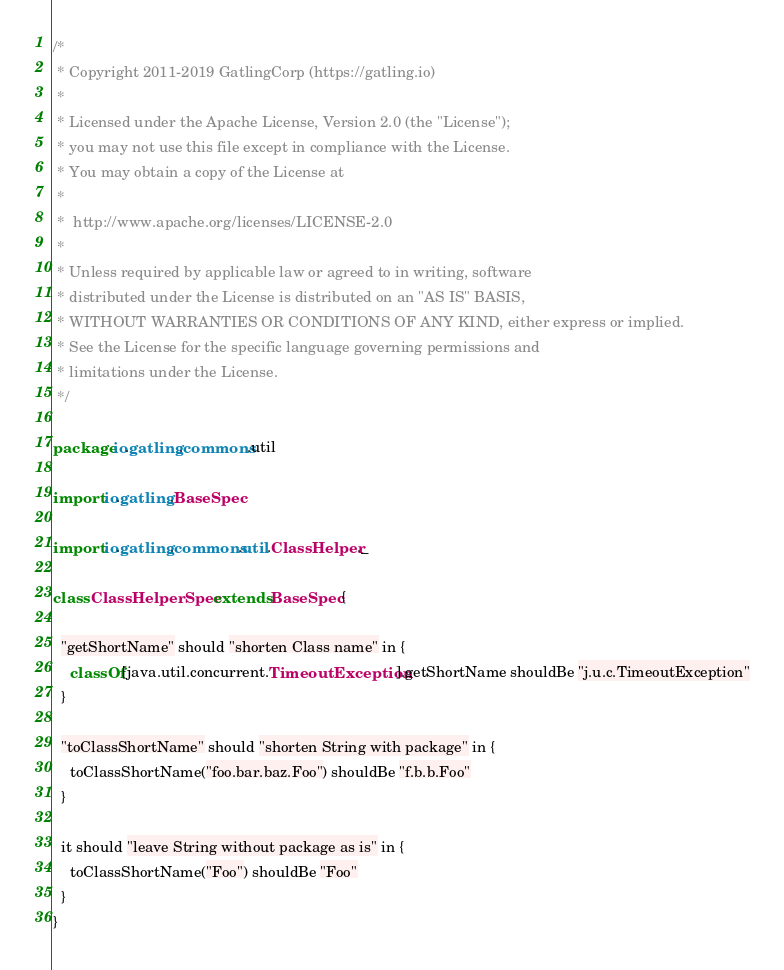Convert code to text. <code><loc_0><loc_0><loc_500><loc_500><_Scala_>/*
 * Copyright 2011-2019 GatlingCorp (https://gatling.io)
 *
 * Licensed under the Apache License, Version 2.0 (the "License");
 * you may not use this file except in compliance with the License.
 * You may obtain a copy of the License at
 *
 *  http://www.apache.org/licenses/LICENSE-2.0
 *
 * Unless required by applicable law or agreed to in writing, software
 * distributed under the License is distributed on an "AS IS" BASIS,
 * WITHOUT WARRANTIES OR CONDITIONS OF ANY KIND, either express or implied.
 * See the License for the specific language governing permissions and
 * limitations under the License.
 */

package io.gatling.commons.util

import io.gatling.BaseSpec

import io.gatling.commons.util.ClassHelper._

class ClassHelperSpec extends BaseSpec {

  "getShortName" should "shorten Class name" in {
    classOf[java.util.concurrent.TimeoutException].getShortName shouldBe "j.u.c.TimeoutException"
  }

  "toClassShortName" should "shorten String with package" in {
    toClassShortName("foo.bar.baz.Foo") shouldBe "f.b.b.Foo"
  }

  it should "leave String without package as is" in {
    toClassShortName("Foo") shouldBe "Foo"
  }
}
</code> 